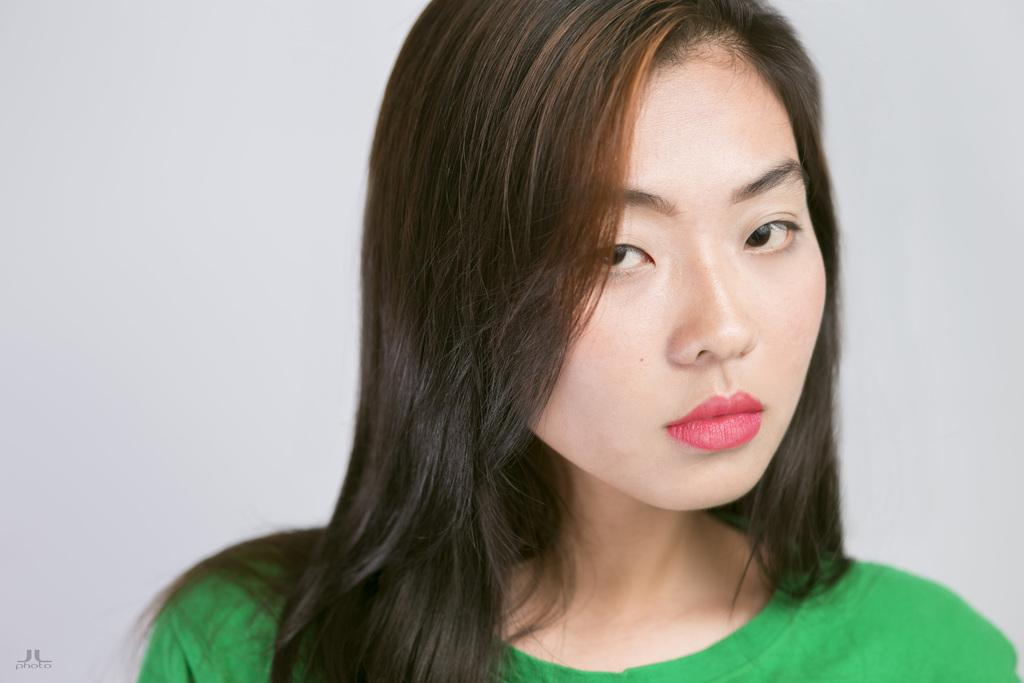Who is present in the image? There is a woman in the image. What is the woman wearing? The woman is wearing a green dress. What is the woman doing in the image? The woman is looking at a picture. What color is the background of the image? The background of the image is white. What type of creature can be seen sleeping on the beds in the image? There are no beds or creatures present in the image; it features a woman looking at a picture with a white background. 